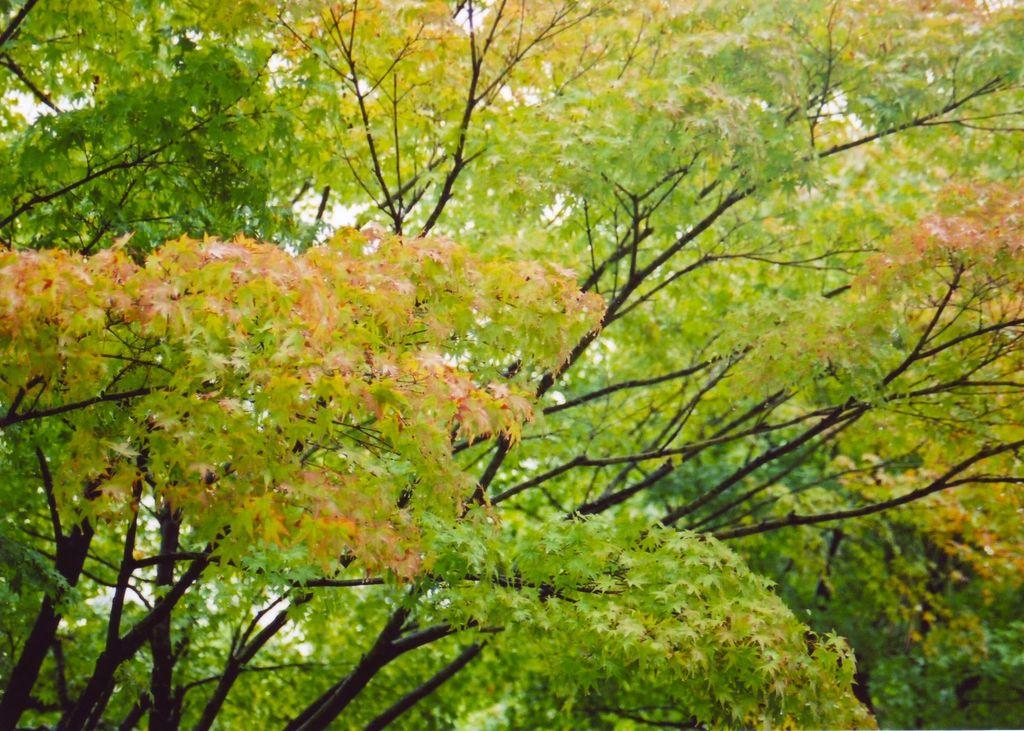What type of vegetation can be seen in the image? There are trees in the image. What type of apple is being eaten with a fork in the image? There is no apple or fork present in the image; it only features trees. 